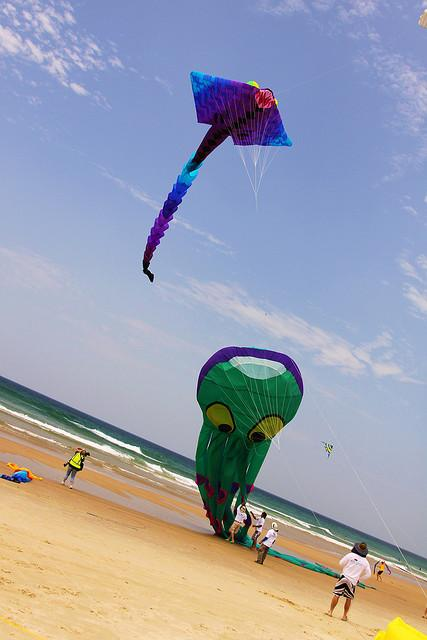How might the real version of the kite animal on top defend itself? Please explain your reasoning. stinger. There is a big animal. 